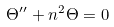<formula> <loc_0><loc_0><loc_500><loc_500>\Theta ^ { \prime \prime } + n ^ { 2 } \Theta = 0</formula> 